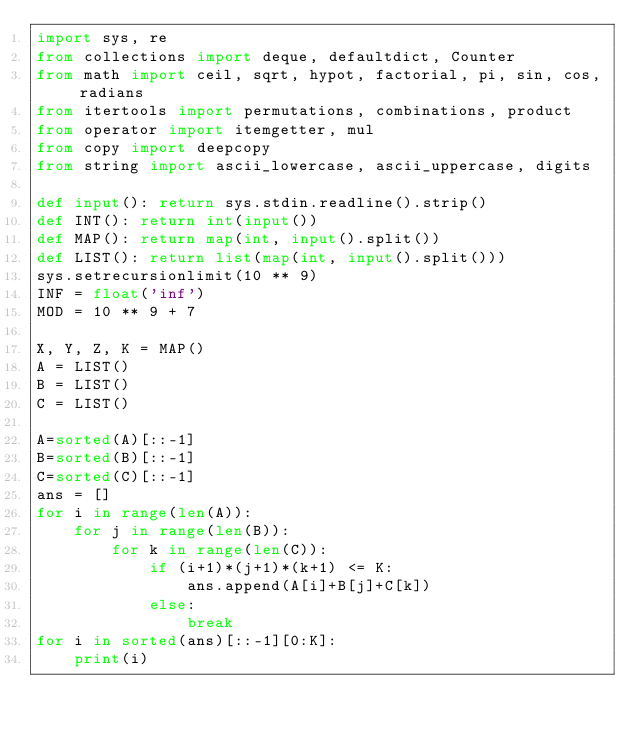Convert code to text. <code><loc_0><loc_0><loc_500><loc_500><_Python_>import sys, re
from collections import deque, defaultdict, Counter
from math import ceil, sqrt, hypot, factorial, pi, sin, cos, radians
from itertools import permutations, combinations, product
from operator import itemgetter, mul
from copy import deepcopy
from string import ascii_lowercase, ascii_uppercase, digits

def input(): return sys.stdin.readline().strip()
def INT(): return int(input())
def MAP(): return map(int, input().split())
def LIST(): return list(map(int, input().split()))
sys.setrecursionlimit(10 ** 9)
INF = float('inf')
MOD = 10 ** 9 + 7

X, Y, Z, K = MAP()
A = LIST()
B = LIST()
C = LIST()

A=sorted(A)[::-1]
B=sorted(B)[::-1]
C=sorted(C)[::-1]
ans = []
for i in range(len(A)):
	for j in range(len(B)):
		for k in range(len(C)):
			if (i+1)*(j+1)*(k+1) <= K:
				ans.append(A[i]+B[j]+C[k])
			else:
				break
for i in sorted(ans)[::-1][0:K]:
	print(i)</code> 